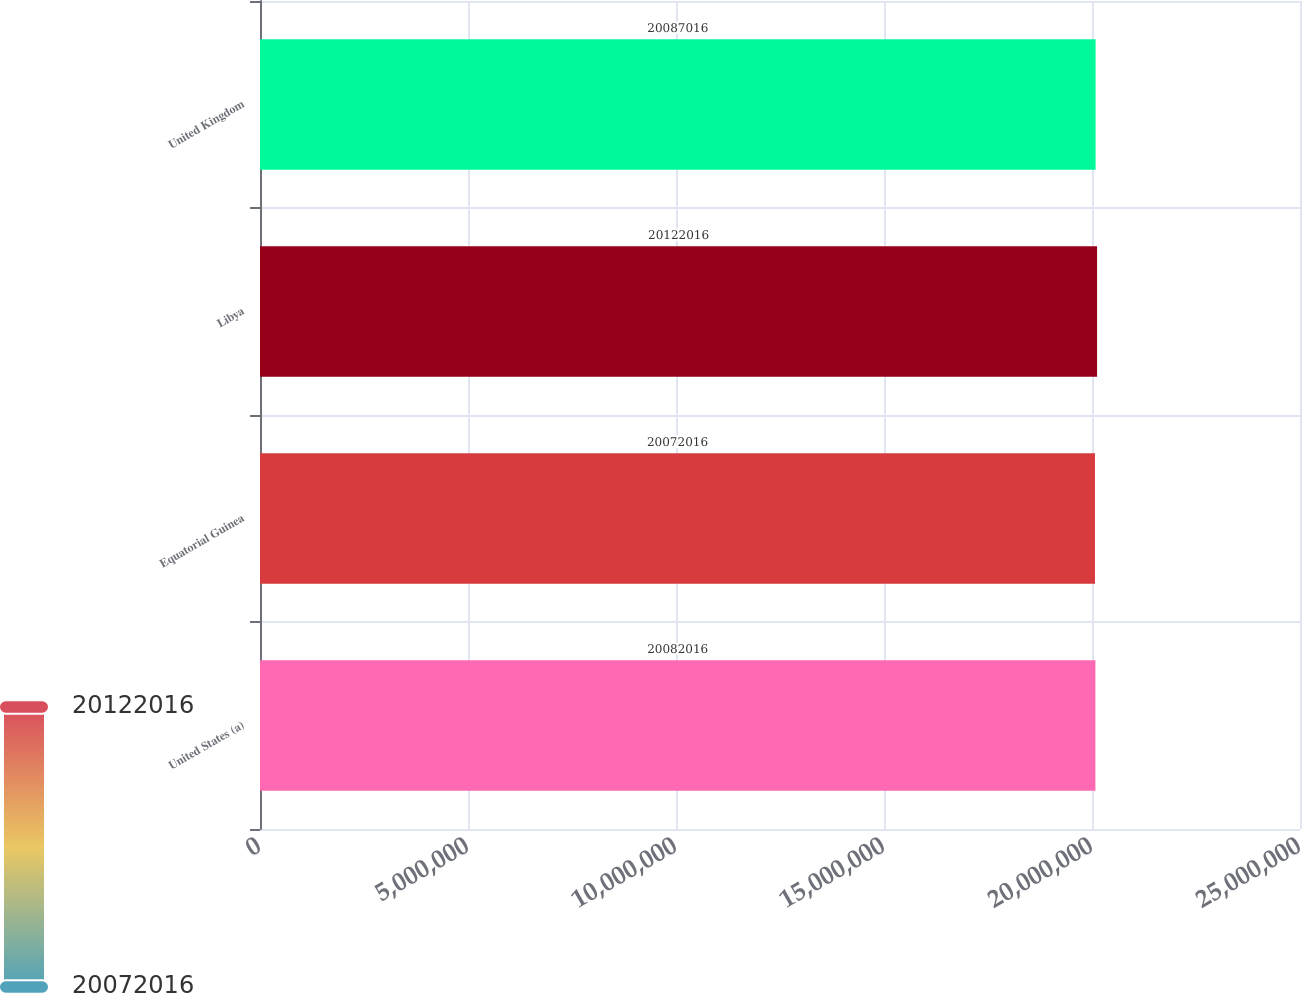<chart> <loc_0><loc_0><loc_500><loc_500><bar_chart><fcel>United States (a)<fcel>Equatorial Guinea<fcel>Libya<fcel>United Kingdom<nl><fcel>2.0082e+07<fcel>2.0072e+07<fcel>2.0122e+07<fcel>2.0087e+07<nl></chart> 